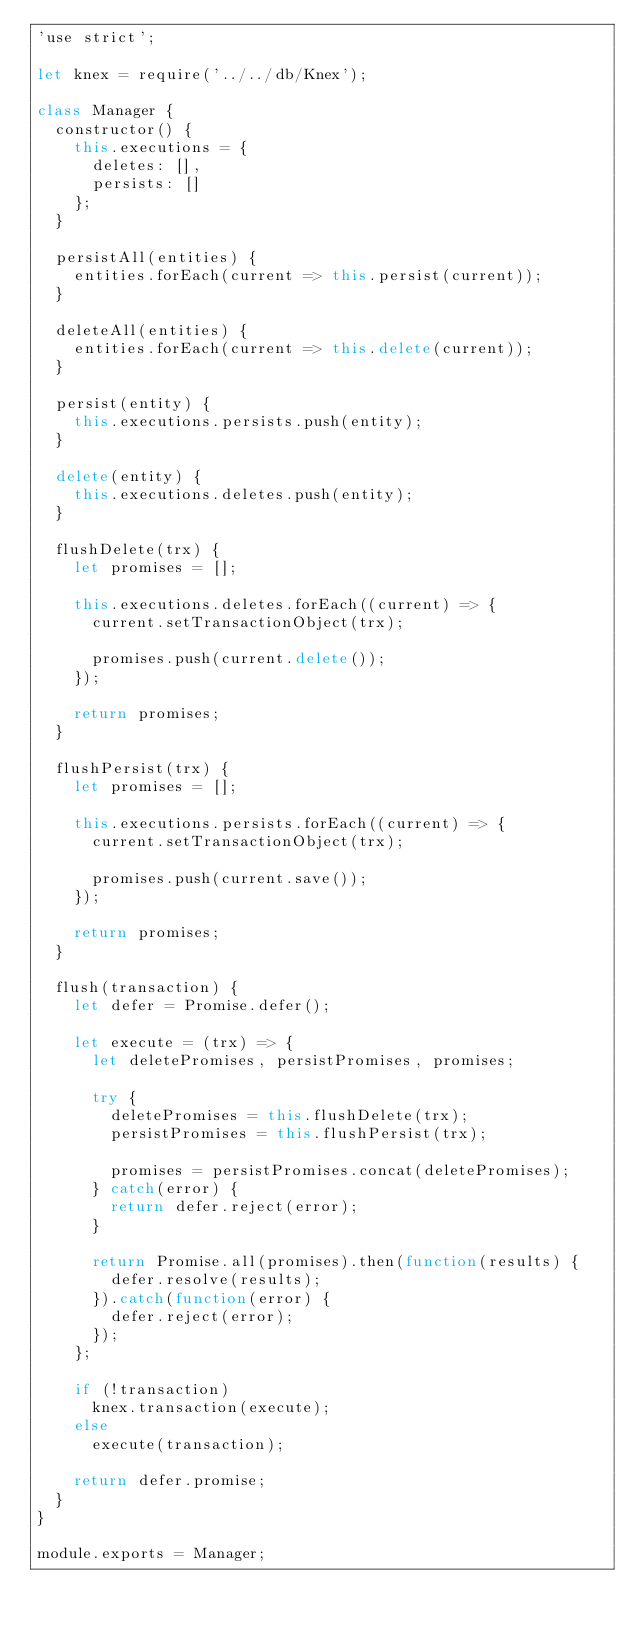Convert code to text. <code><loc_0><loc_0><loc_500><loc_500><_JavaScript_>'use strict';

let knex = require('../../db/Knex');

class Manager {
	constructor() {
		this.executions = {
			deletes: [],
			persists: []
		};
	}

	persistAll(entities) {
		entities.forEach(current => this.persist(current));
	}

	deleteAll(entities) {
		entities.forEach(current => this.delete(current));
	}

	persist(entity) {
		this.executions.persists.push(entity);
	}

	delete(entity) {
		this.executions.deletes.push(entity);
	}

	flushDelete(trx) {
		let promises = [];

		this.executions.deletes.forEach((current) => {
			current.setTransactionObject(trx);

			promises.push(current.delete());
		});

		return promises;
	}

	flushPersist(trx) {
		let promises = [];

		this.executions.persists.forEach((current) => {
			current.setTransactionObject(trx);

			promises.push(current.save());
		});

		return promises;
	}

	flush(transaction) {
		let defer = Promise.defer();

		let execute = (trx) => {
			let deletePromises, persistPromises, promises;

			try {
				deletePromises = this.flushDelete(trx);
				persistPromises = this.flushPersist(trx);

				promises = persistPromises.concat(deletePromises);
			} catch(error) {
				return defer.reject(error);
			}

			return Promise.all(promises).then(function(results) {
				defer.resolve(results);
			}).catch(function(error) {
				defer.reject(error);
			});
		};

		if (!transaction)
			knex.transaction(execute);
		else
			execute(transaction);

		return defer.promise;
	}
}

module.exports = Manager;</code> 